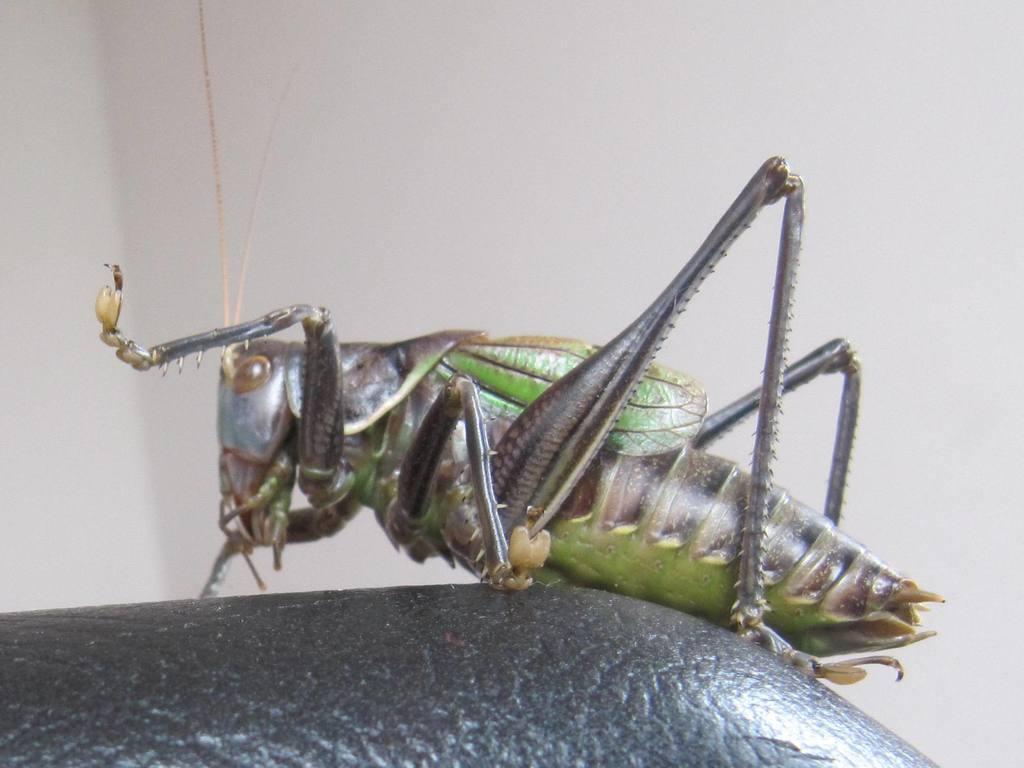In one or two sentences, can you explain what this image depicts? In the center of the image we can see insect on table. In the background there is wall. 